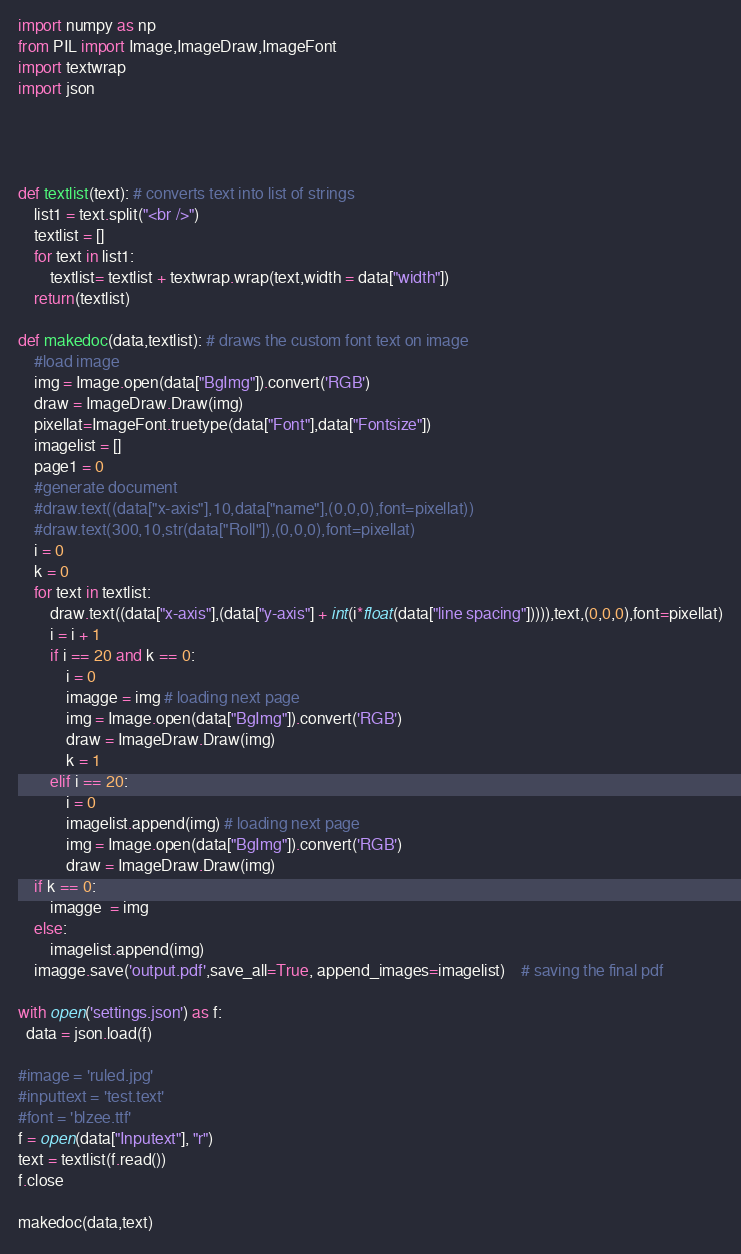Convert code to text. <code><loc_0><loc_0><loc_500><loc_500><_Python_>import numpy as np
from PIL import Image,ImageDraw,ImageFont
import textwrap
import json


 

def textlist(text): # converts text into list of strings
	list1 = text.split("<br />")
	textlist = []
	for text in list1:
		textlist= textlist + textwrap.wrap(text,width = data["width"])
	return(textlist)

def makedoc(data,textlist): # draws the custom font text on image 
	#load image 
	img = Image.open(data["BgImg"]).convert('RGB')
	draw = ImageDraw.Draw(img)
	pixellat=ImageFont.truetype(data["Font"],data["Fontsize"])
	imagelist = []
	page1 = 0
	#generate document
	#draw.text((data["x-axis"],10,data["name"],(0,0,0),font=pixellat))
	#draw.text(300,10,str(data["Roll"]),(0,0,0),font=pixellat)
	i = 0
	k = 0 
	for text in textlist:
		draw.text((data["x-axis"],(data["y-axis"] + int(i*float(data["line spacing"])))),text,(0,0,0),font=pixellat)
		i = i + 1
		if i == 20 and k == 0:
			i = 0
			imagge = img # loading next page
			img = Image.open(data["BgImg"]).convert('RGB')
			draw = ImageDraw.Draw(img)
			k = 1
		elif i == 20:
			i = 0
			imagelist.append(img) # loading next page
			img = Image.open(data["BgImg"]).convert('RGB')
			draw = ImageDraw.Draw(img)
	if k == 0:
		imagge  = img
	else:
		imagelist.append(img)	
	imagge.save('output.pdf',save_all=True, append_images=imagelist)	# saving the final pdf
 	
with open('settings.json') as f:
  data = json.load(f)
	
#image = 'ruled.jpg'
#inputtext = 'test.text'
#font = 'blzee.ttf'
f = open(data["Inputext"], "r")
text = textlist(f.read())
f.close

makedoc(data,text)





</code> 